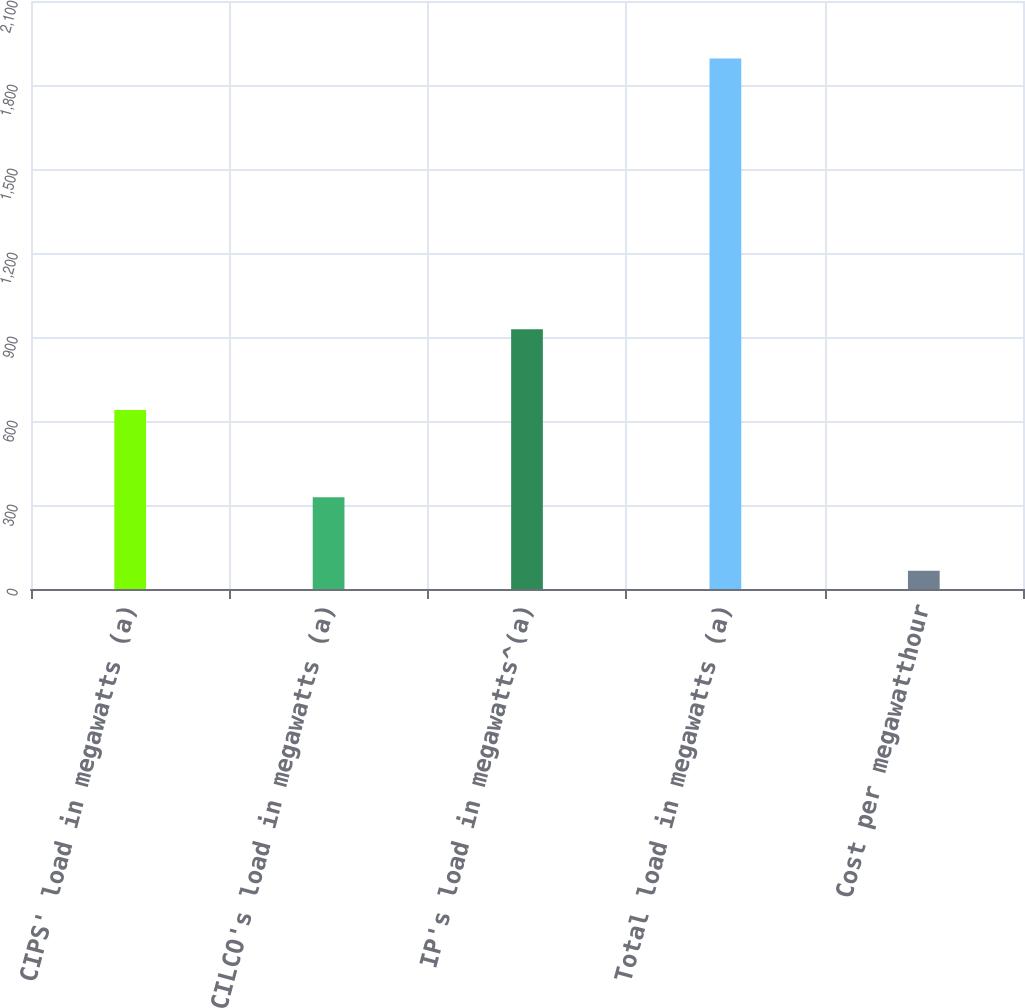Convert chart. <chart><loc_0><loc_0><loc_500><loc_500><bar_chart><fcel>CIPS' load in megawatts (a)<fcel>CILCO's load in megawatts (a)<fcel>IP's load in megawatts^(a)<fcel>Total load in megawatts (a)<fcel>Cost per megawatthour<nl><fcel>639<fcel>328<fcel>928<fcel>1895<fcel>64.75<nl></chart> 